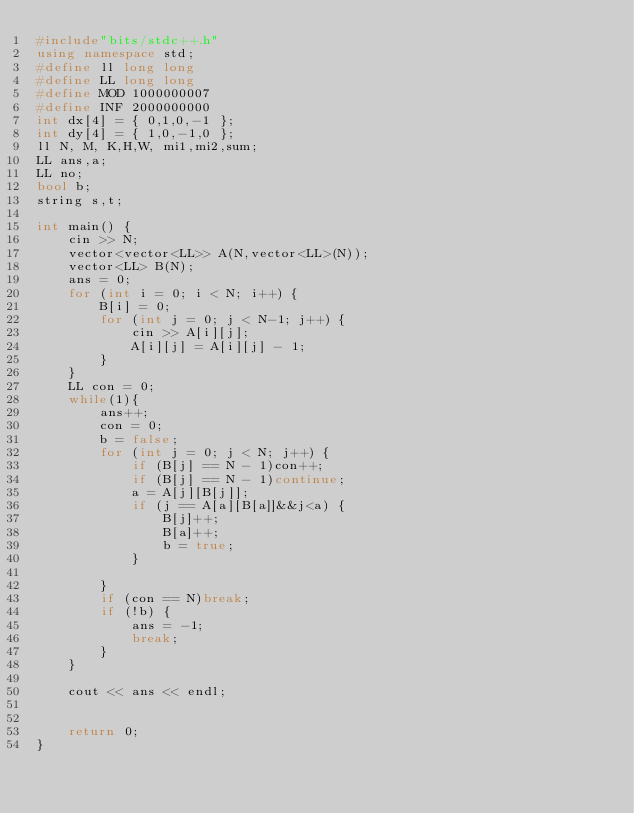<code> <loc_0><loc_0><loc_500><loc_500><_C++_>#include"bits/stdc++.h"
using namespace std;
#define ll long long
#define LL long long
#define MOD 1000000007
#define INF 2000000000
int dx[4] = { 0,1,0,-1 };
int dy[4] = { 1,0,-1,0 };
ll N, M, K,H,W, mi1,mi2,sum;
LL ans,a;
LL no;
bool b;
string s,t;

int main() {
	cin >> N;
	vector<vector<LL>> A(N,vector<LL>(N));
	vector<LL> B(N);
	ans = 0;
	for (int i = 0; i < N; i++) {
		B[i] = 0;
		for (int j = 0; j < N-1; j++) {
			cin >> A[i][j];
			A[i][j] = A[i][j] - 1;
		}
	}
	LL con = 0;
	while(1){
		ans++;
		con = 0;
		b = false;
		for (int j = 0; j < N; j++) {
			if (B[j] == N - 1)con++;
			if (B[j] == N - 1)continue;
			a = A[j][B[j]];
			if (j == A[a][B[a]]&&j<a) {
				B[j]++;
				B[a]++;
				b = true;
			}

		}
		if (con == N)break;
		if (!b) {
			ans = -1;
			break;
		}
	}

	cout << ans << endl;


	return 0;
}

</code> 